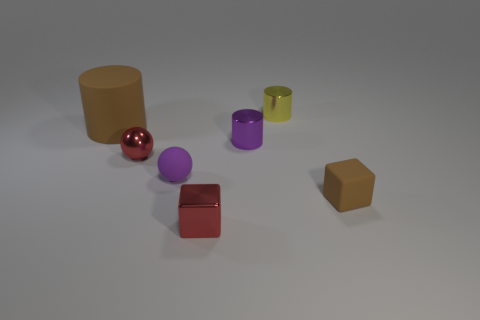Subtract all tiny metallic cylinders. How many cylinders are left? 1 Subtract all yellow cylinders. How many cylinders are left? 2 Add 2 small objects. How many objects exist? 9 Subtract all spheres. How many objects are left? 5 Subtract all green cubes. How many purple spheres are left? 1 Subtract 0 blue blocks. How many objects are left? 7 Subtract 3 cylinders. How many cylinders are left? 0 Subtract all red balls. Subtract all blue cubes. How many balls are left? 1 Subtract all big cyan shiny spheres. Subtract all matte spheres. How many objects are left? 6 Add 7 small red things. How many small red things are left? 9 